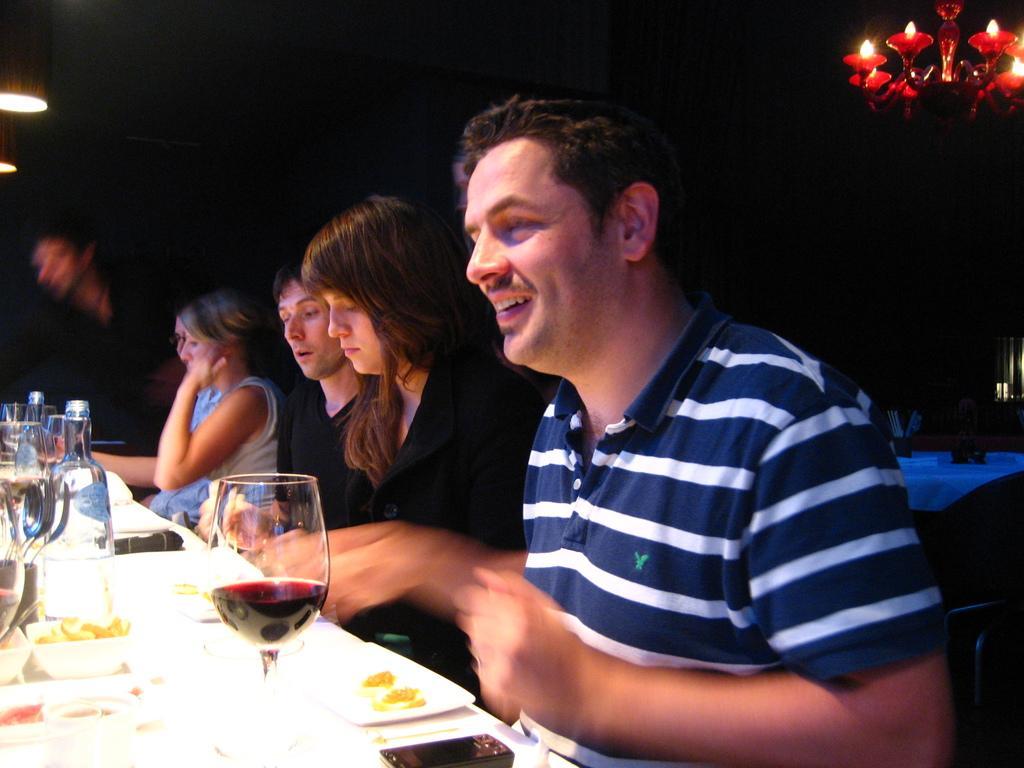Please provide a concise description of this image. This is the picture of the group of people who are sitting on the chair in front of them there is a table, on the table there is a glass jar and a wine glass on the table there is a mobile. Background of this people is a black color and a chandelier hanging to the roof. 